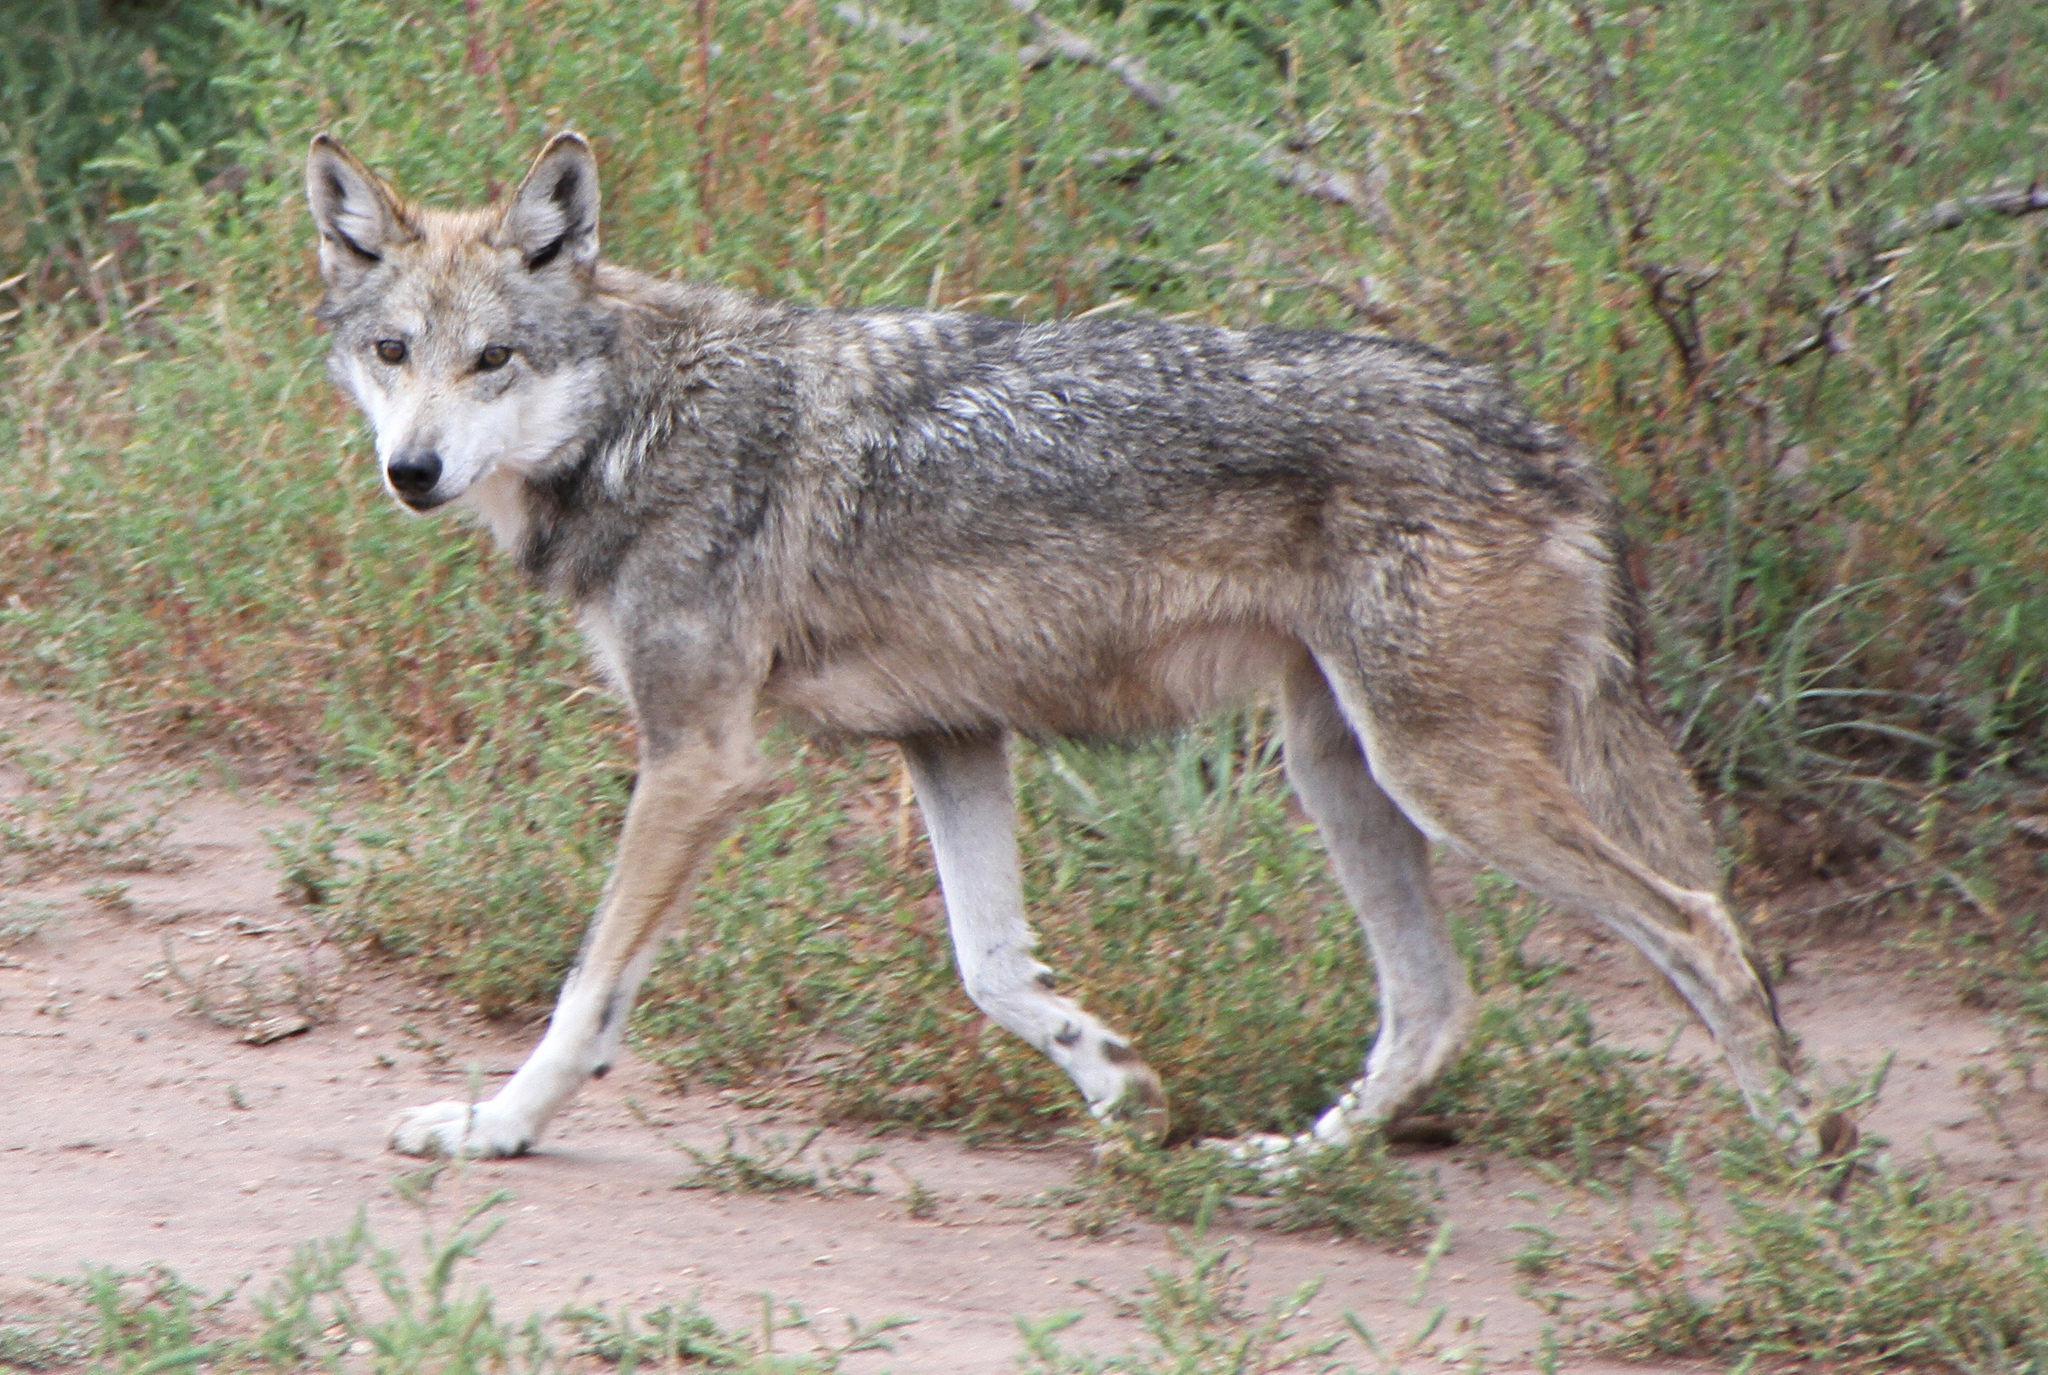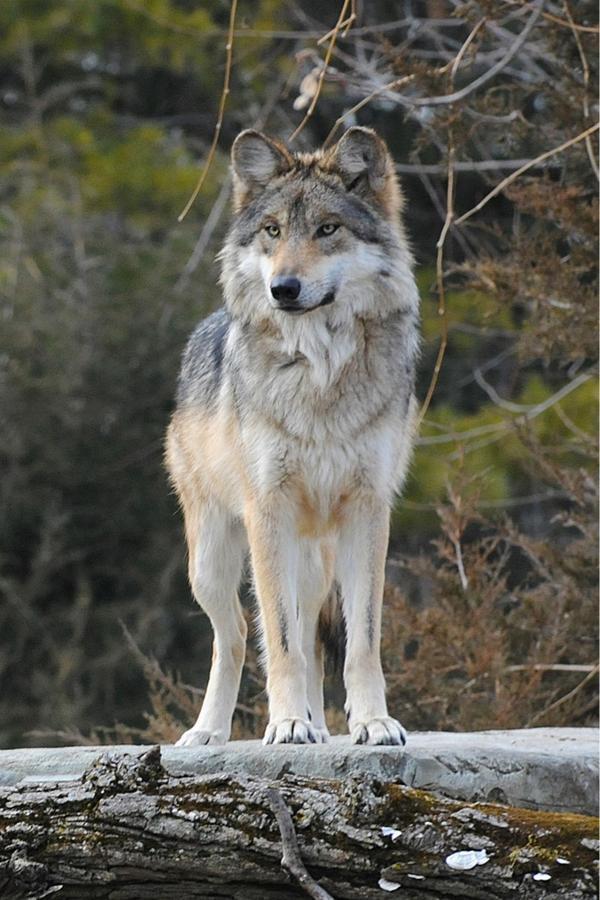The first image is the image on the left, the second image is the image on the right. Evaluate the accuracy of this statement regarding the images: "in the left image there is a wold walking on snow covered ground with twigs sticking up through the snow". Is it true? Answer yes or no. No. The first image is the image on the left, the second image is the image on the right. Given the left and right images, does the statement "The right image contains one forward turned wolf that is standing still and gazing ahead with a raised neck and head, and the left image contains one wolf walking leftward." hold true? Answer yes or no. Yes. 